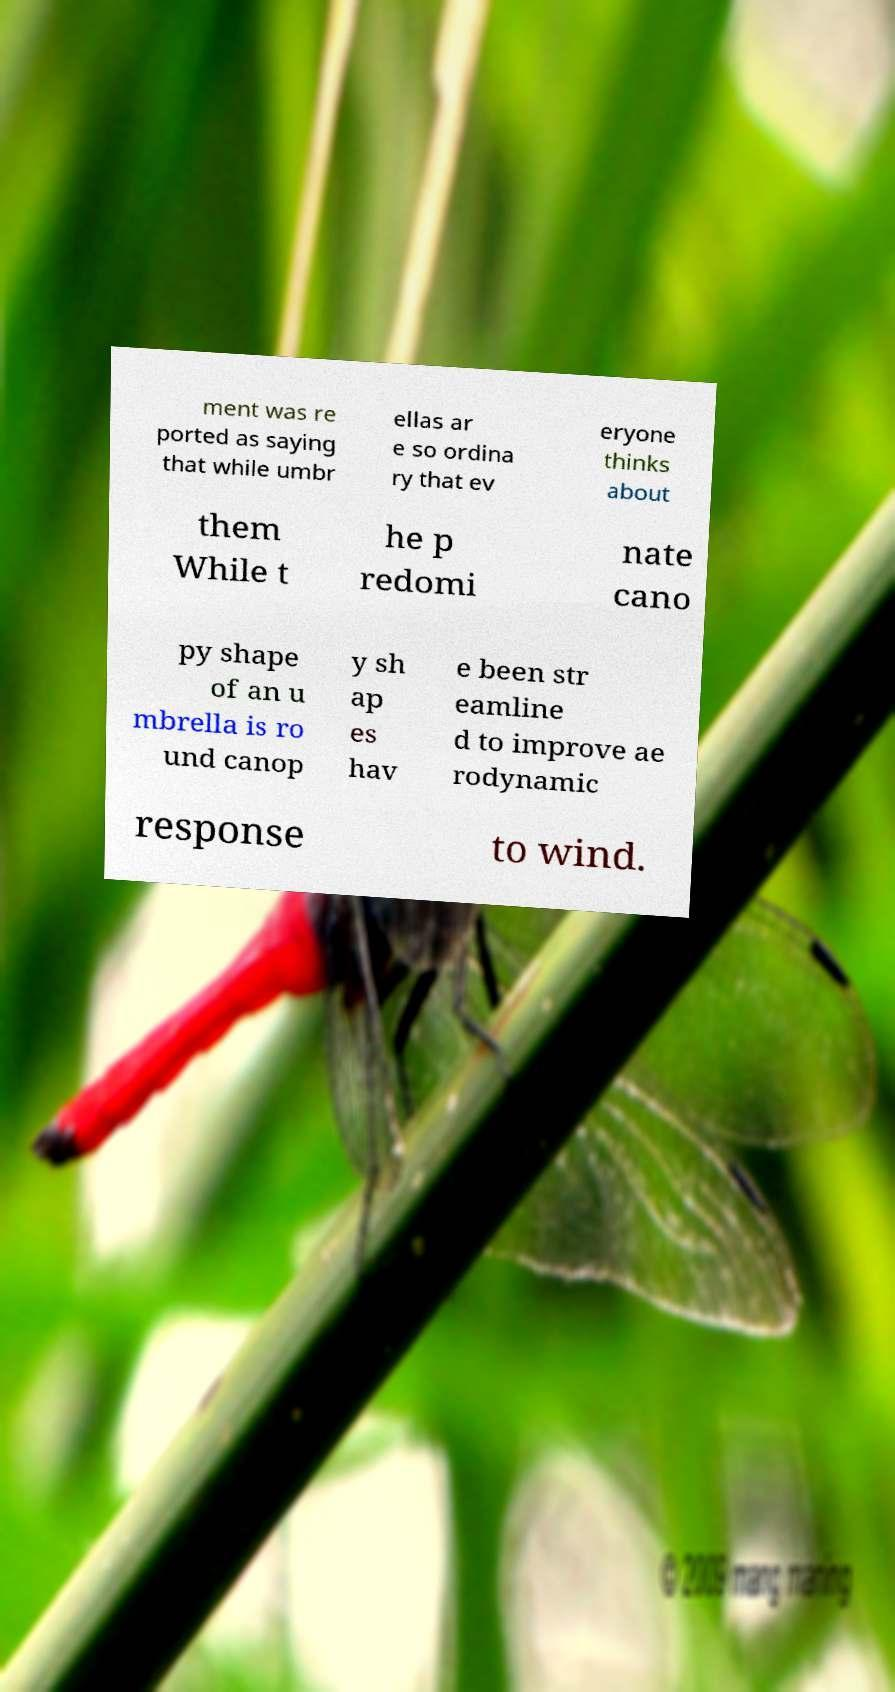For documentation purposes, I need the text within this image transcribed. Could you provide that? ment was re ported as saying that while umbr ellas ar e so ordina ry that ev eryone thinks about them While t he p redomi nate cano py shape of an u mbrella is ro und canop y sh ap es hav e been str eamline d to improve ae rodynamic response to wind. 